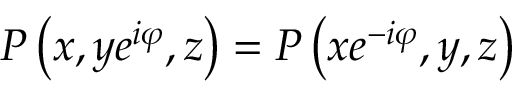Convert formula to latex. <formula><loc_0><loc_0><loc_500><loc_500>P \left ( x , y e ^ { i \varphi } , z \right ) = P \left ( x e ^ { - i \varphi } , y , z \right )</formula> 